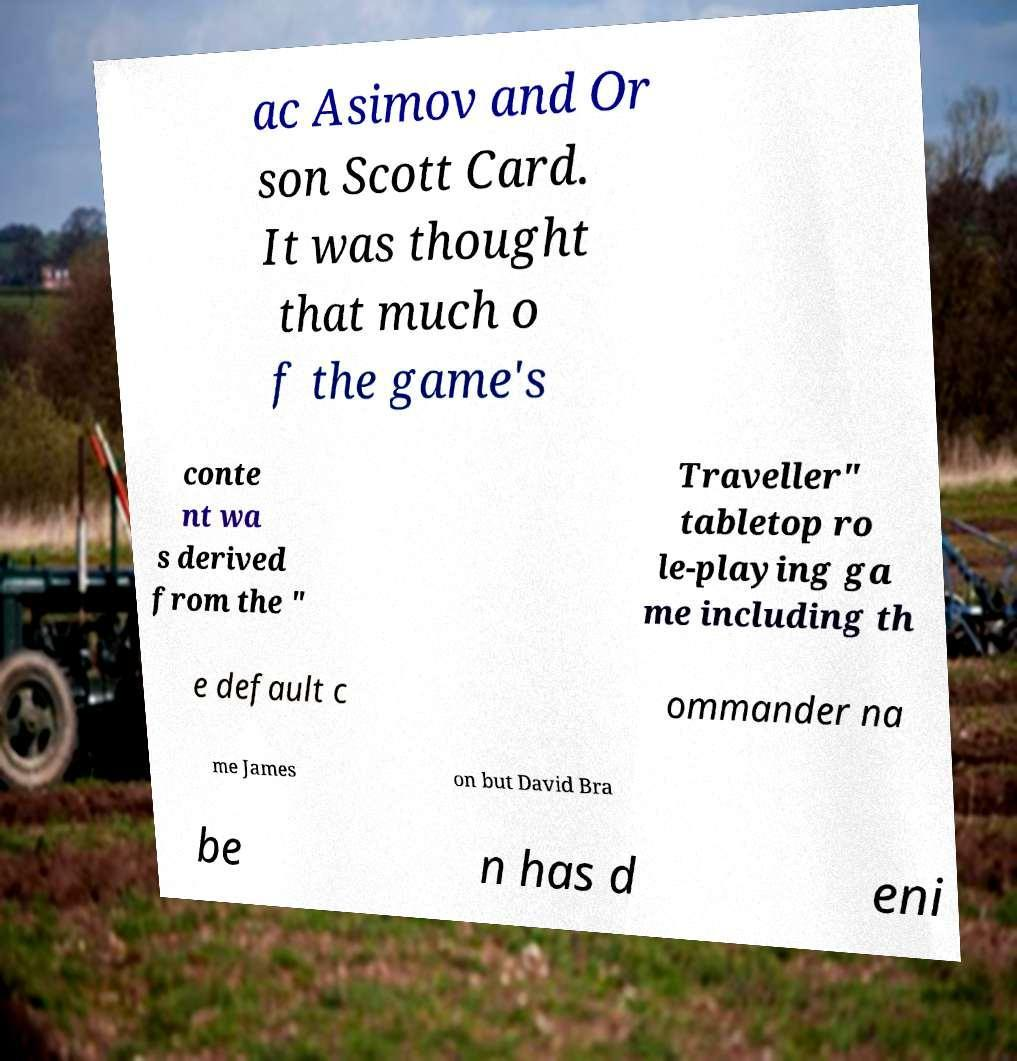Please identify and transcribe the text found in this image. ac Asimov and Or son Scott Card. It was thought that much o f the game's conte nt wa s derived from the " Traveller" tabletop ro le-playing ga me including th e default c ommander na me James on but David Bra be n has d eni 